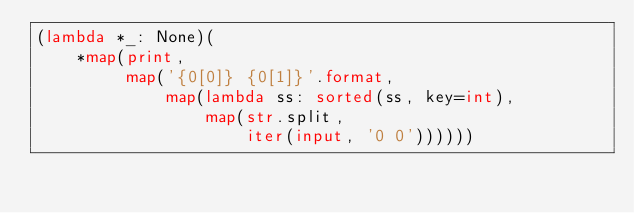Convert code to text. <code><loc_0><loc_0><loc_500><loc_500><_Python_>(lambda *_: None)(
    *map(print,
         map('{0[0]} {0[1]}'.format,
             map(lambda ss: sorted(ss, key=int),
                 map(str.split,
                     iter(input, '0 0'))))))</code> 